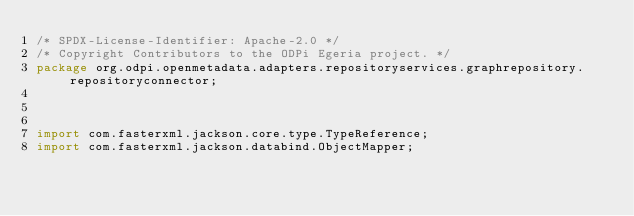Convert code to text. <code><loc_0><loc_0><loc_500><loc_500><_Java_>/* SPDX-License-Identifier: Apache-2.0 */
/* Copyright Contributors to the ODPi Egeria project. */
package org.odpi.openmetadata.adapters.repositoryservices.graphrepository.repositoryconnector;



import com.fasterxml.jackson.core.type.TypeReference;
import com.fasterxml.jackson.databind.ObjectMapper;</code> 